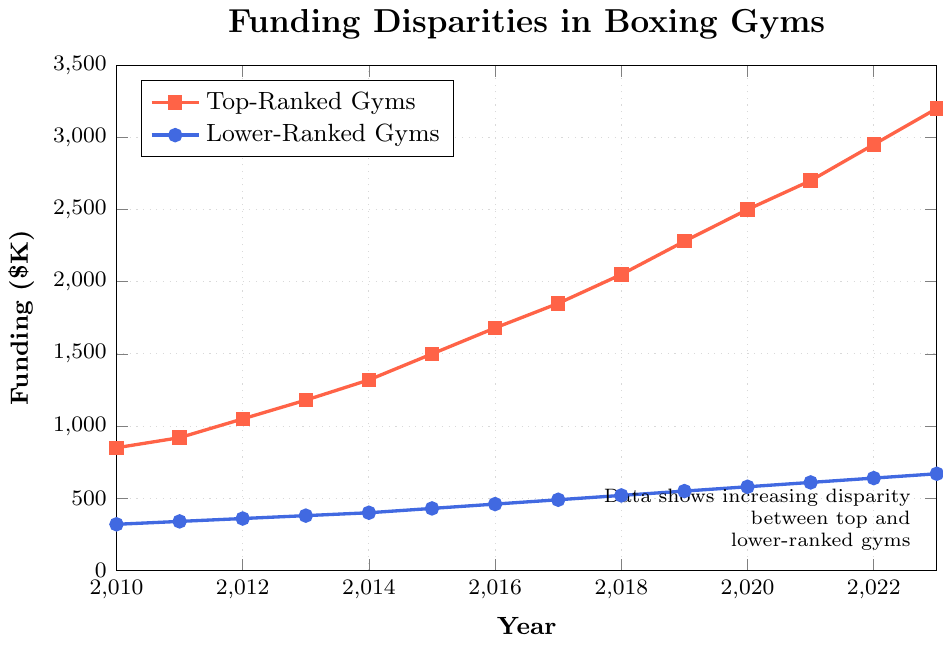What's the funding gap between top-ranked and lower-ranked boxing gyms in 2010? The funding for top-ranked gyms in 2010 is $850K, while for lower-ranked gyms, it is $320K. The gap is $850K - $320K.
Answer: $530K By how much did the funding for top-ranked boxing gyms increase from 2010 to 2023? Funding for top-ranked gyms in 2010 was $850K and in 2023 it was $3200K. The increase is $3200K - $850K.
Answer: $2350K Did the lower-ranked boxing gyms' funding ever exceed $600K? Checking the data, the lower-ranked gyms' funding was $610K in 2021 and onwards.
Answer: Yes In which year was the funding for top-ranked gyms double that of lower-ranked gyms? Comparison shows that in 2016, top-ranked gyms had $1680K while lower-ranked gyms had $460K, approximately double the funding (460K*2 ≈ 920K).
Answer: 2016 How much more funding did top-ranked gyms receive than lower-ranked gyms in 2020? Top-ranked gyms received $2500K, and lower-ranked gyms $580K in 2020. The difference is $2500K - $580K.
Answer: $1920K What is the average annual funding for lower-ranked gyms over the period 2010 to 2023? Summing the annual funding for lower-ranked gyms gives $320K + $340K + $360K + $380K + $400K + $430K + $460K + $490K + $520K + $550K + $580K + $610K + $640K + $670K = $6750K. There are 14 years, hence the average is $6750K / 14.
Answer: $482.14K When did top-ranked gyms first receive more than $1500K in funding? Reviewing the data shows that top-ranked gyms first received more than $1500K in 2015 when their funding was $1500K.
Answer: 2015 What's the difference in funding growth rate between top-ranked and lower-ranked gyms from 2010 to 2023? Top-ranked gyms increased from $850K to $3200K, a growth of $3200K - $850K = $2350K. Lower-ranked gyms increased from $320K to $670K, a growth of $670K - $320K = $350K.
Answer: $2000K Which year saw the highest annual increase in funding for lower-ranked gyms? By comparing year-over-year funding increases in the data, the highest increase for lower-ranked gyms was from $400K in 2014 to $430K in 2015, an increase of $430K - $400K = $30K.
Answer: 2015 